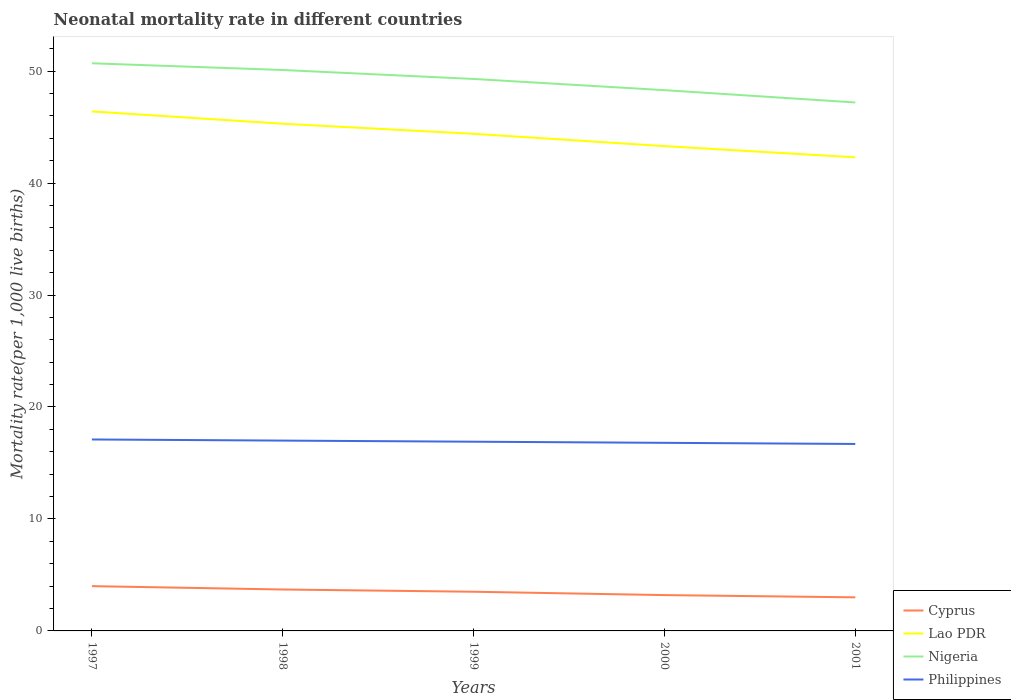How many different coloured lines are there?
Ensure brevity in your answer.  4. Is the number of lines equal to the number of legend labels?
Make the answer very short. Yes. Across all years, what is the maximum neonatal mortality rate in Lao PDR?
Offer a terse response. 42.3. What is the total neonatal mortality rate in Nigeria in the graph?
Your response must be concise. 0.6. What is the difference between the highest and the second highest neonatal mortality rate in Lao PDR?
Offer a terse response. 4.1. What is the difference between the highest and the lowest neonatal mortality rate in Nigeria?
Your answer should be very brief. 3. What is the difference between two consecutive major ticks on the Y-axis?
Make the answer very short. 10. Does the graph contain grids?
Offer a terse response. No. Where does the legend appear in the graph?
Ensure brevity in your answer.  Bottom right. How many legend labels are there?
Provide a succinct answer. 4. What is the title of the graph?
Offer a terse response. Neonatal mortality rate in different countries. Does "Andorra" appear as one of the legend labels in the graph?
Your answer should be compact. No. What is the label or title of the X-axis?
Keep it short and to the point. Years. What is the label or title of the Y-axis?
Provide a succinct answer. Mortality rate(per 1,0 live births). What is the Mortality rate(per 1,000 live births) of Cyprus in 1997?
Your response must be concise. 4. What is the Mortality rate(per 1,000 live births) in Lao PDR in 1997?
Provide a succinct answer. 46.4. What is the Mortality rate(per 1,000 live births) in Nigeria in 1997?
Provide a succinct answer. 50.7. What is the Mortality rate(per 1,000 live births) in Philippines in 1997?
Your answer should be very brief. 17.1. What is the Mortality rate(per 1,000 live births) of Cyprus in 1998?
Make the answer very short. 3.7. What is the Mortality rate(per 1,000 live births) of Lao PDR in 1998?
Give a very brief answer. 45.3. What is the Mortality rate(per 1,000 live births) of Nigeria in 1998?
Your answer should be compact. 50.1. What is the Mortality rate(per 1,000 live births) in Cyprus in 1999?
Give a very brief answer. 3.5. What is the Mortality rate(per 1,000 live births) of Lao PDR in 1999?
Your response must be concise. 44.4. What is the Mortality rate(per 1,000 live births) in Nigeria in 1999?
Offer a very short reply. 49.3. What is the Mortality rate(per 1,000 live births) in Cyprus in 2000?
Offer a very short reply. 3.2. What is the Mortality rate(per 1,000 live births) of Lao PDR in 2000?
Provide a succinct answer. 43.3. What is the Mortality rate(per 1,000 live births) of Nigeria in 2000?
Make the answer very short. 48.3. What is the Mortality rate(per 1,000 live births) of Philippines in 2000?
Make the answer very short. 16.8. What is the Mortality rate(per 1,000 live births) of Cyprus in 2001?
Provide a succinct answer. 3. What is the Mortality rate(per 1,000 live births) of Lao PDR in 2001?
Ensure brevity in your answer.  42.3. What is the Mortality rate(per 1,000 live births) of Nigeria in 2001?
Offer a terse response. 47.2. What is the Mortality rate(per 1,000 live births) of Philippines in 2001?
Give a very brief answer. 16.7. Across all years, what is the maximum Mortality rate(per 1,000 live births) in Cyprus?
Your answer should be compact. 4. Across all years, what is the maximum Mortality rate(per 1,000 live births) in Lao PDR?
Ensure brevity in your answer.  46.4. Across all years, what is the maximum Mortality rate(per 1,000 live births) of Nigeria?
Offer a very short reply. 50.7. Across all years, what is the minimum Mortality rate(per 1,000 live births) of Cyprus?
Ensure brevity in your answer.  3. Across all years, what is the minimum Mortality rate(per 1,000 live births) in Lao PDR?
Offer a very short reply. 42.3. Across all years, what is the minimum Mortality rate(per 1,000 live births) in Nigeria?
Give a very brief answer. 47.2. What is the total Mortality rate(per 1,000 live births) of Lao PDR in the graph?
Your response must be concise. 221.7. What is the total Mortality rate(per 1,000 live births) of Nigeria in the graph?
Keep it short and to the point. 245.6. What is the total Mortality rate(per 1,000 live births) of Philippines in the graph?
Your answer should be compact. 84.5. What is the difference between the Mortality rate(per 1,000 live births) in Cyprus in 1997 and that in 1998?
Provide a short and direct response. 0.3. What is the difference between the Mortality rate(per 1,000 live births) of Lao PDR in 1997 and that in 1999?
Keep it short and to the point. 2. What is the difference between the Mortality rate(per 1,000 live births) in Philippines in 1997 and that in 1999?
Your response must be concise. 0.2. What is the difference between the Mortality rate(per 1,000 live births) of Nigeria in 1997 and that in 2000?
Offer a very short reply. 2.4. What is the difference between the Mortality rate(per 1,000 live births) in Cyprus in 1997 and that in 2001?
Provide a short and direct response. 1. What is the difference between the Mortality rate(per 1,000 live births) in Lao PDR in 1997 and that in 2001?
Offer a very short reply. 4.1. What is the difference between the Mortality rate(per 1,000 live births) in Nigeria in 1997 and that in 2001?
Keep it short and to the point. 3.5. What is the difference between the Mortality rate(per 1,000 live births) in Cyprus in 1998 and that in 1999?
Keep it short and to the point. 0.2. What is the difference between the Mortality rate(per 1,000 live births) in Lao PDR in 1998 and that in 1999?
Offer a very short reply. 0.9. What is the difference between the Mortality rate(per 1,000 live births) of Nigeria in 1998 and that in 1999?
Your response must be concise. 0.8. What is the difference between the Mortality rate(per 1,000 live births) of Nigeria in 1998 and that in 2000?
Offer a terse response. 1.8. What is the difference between the Mortality rate(per 1,000 live births) of Cyprus in 1998 and that in 2001?
Your answer should be very brief. 0.7. What is the difference between the Mortality rate(per 1,000 live births) of Nigeria in 1998 and that in 2001?
Offer a very short reply. 2.9. What is the difference between the Mortality rate(per 1,000 live births) of Philippines in 1998 and that in 2001?
Provide a short and direct response. 0.3. What is the difference between the Mortality rate(per 1,000 live births) of Cyprus in 1999 and that in 2000?
Your answer should be very brief. 0.3. What is the difference between the Mortality rate(per 1,000 live births) in Lao PDR in 1999 and that in 2000?
Your answer should be very brief. 1.1. What is the difference between the Mortality rate(per 1,000 live births) in Nigeria in 1999 and that in 2000?
Offer a very short reply. 1. What is the difference between the Mortality rate(per 1,000 live births) in Cyprus in 1999 and that in 2001?
Give a very brief answer. 0.5. What is the difference between the Mortality rate(per 1,000 live births) of Lao PDR in 1999 and that in 2001?
Offer a very short reply. 2.1. What is the difference between the Mortality rate(per 1,000 live births) in Nigeria in 1999 and that in 2001?
Make the answer very short. 2.1. What is the difference between the Mortality rate(per 1,000 live births) of Nigeria in 2000 and that in 2001?
Offer a terse response. 1.1. What is the difference between the Mortality rate(per 1,000 live births) in Philippines in 2000 and that in 2001?
Provide a succinct answer. 0.1. What is the difference between the Mortality rate(per 1,000 live births) of Cyprus in 1997 and the Mortality rate(per 1,000 live births) of Lao PDR in 1998?
Offer a very short reply. -41.3. What is the difference between the Mortality rate(per 1,000 live births) in Cyprus in 1997 and the Mortality rate(per 1,000 live births) in Nigeria in 1998?
Provide a succinct answer. -46.1. What is the difference between the Mortality rate(per 1,000 live births) in Cyprus in 1997 and the Mortality rate(per 1,000 live births) in Philippines in 1998?
Provide a short and direct response. -13. What is the difference between the Mortality rate(per 1,000 live births) in Lao PDR in 1997 and the Mortality rate(per 1,000 live births) in Nigeria in 1998?
Provide a succinct answer. -3.7. What is the difference between the Mortality rate(per 1,000 live births) in Lao PDR in 1997 and the Mortality rate(per 1,000 live births) in Philippines in 1998?
Your answer should be compact. 29.4. What is the difference between the Mortality rate(per 1,000 live births) in Nigeria in 1997 and the Mortality rate(per 1,000 live births) in Philippines in 1998?
Your response must be concise. 33.7. What is the difference between the Mortality rate(per 1,000 live births) of Cyprus in 1997 and the Mortality rate(per 1,000 live births) of Lao PDR in 1999?
Your response must be concise. -40.4. What is the difference between the Mortality rate(per 1,000 live births) of Cyprus in 1997 and the Mortality rate(per 1,000 live births) of Nigeria in 1999?
Provide a short and direct response. -45.3. What is the difference between the Mortality rate(per 1,000 live births) of Cyprus in 1997 and the Mortality rate(per 1,000 live births) of Philippines in 1999?
Your answer should be compact. -12.9. What is the difference between the Mortality rate(per 1,000 live births) of Lao PDR in 1997 and the Mortality rate(per 1,000 live births) of Nigeria in 1999?
Offer a very short reply. -2.9. What is the difference between the Mortality rate(per 1,000 live births) of Lao PDR in 1997 and the Mortality rate(per 1,000 live births) of Philippines in 1999?
Ensure brevity in your answer.  29.5. What is the difference between the Mortality rate(per 1,000 live births) of Nigeria in 1997 and the Mortality rate(per 1,000 live births) of Philippines in 1999?
Make the answer very short. 33.8. What is the difference between the Mortality rate(per 1,000 live births) in Cyprus in 1997 and the Mortality rate(per 1,000 live births) in Lao PDR in 2000?
Your answer should be very brief. -39.3. What is the difference between the Mortality rate(per 1,000 live births) of Cyprus in 1997 and the Mortality rate(per 1,000 live births) of Nigeria in 2000?
Your answer should be very brief. -44.3. What is the difference between the Mortality rate(per 1,000 live births) of Cyprus in 1997 and the Mortality rate(per 1,000 live births) of Philippines in 2000?
Your response must be concise. -12.8. What is the difference between the Mortality rate(per 1,000 live births) of Lao PDR in 1997 and the Mortality rate(per 1,000 live births) of Philippines in 2000?
Ensure brevity in your answer.  29.6. What is the difference between the Mortality rate(per 1,000 live births) of Nigeria in 1997 and the Mortality rate(per 1,000 live births) of Philippines in 2000?
Offer a very short reply. 33.9. What is the difference between the Mortality rate(per 1,000 live births) in Cyprus in 1997 and the Mortality rate(per 1,000 live births) in Lao PDR in 2001?
Your answer should be compact. -38.3. What is the difference between the Mortality rate(per 1,000 live births) of Cyprus in 1997 and the Mortality rate(per 1,000 live births) of Nigeria in 2001?
Make the answer very short. -43.2. What is the difference between the Mortality rate(per 1,000 live births) of Cyprus in 1997 and the Mortality rate(per 1,000 live births) of Philippines in 2001?
Ensure brevity in your answer.  -12.7. What is the difference between the Mortality rate(per 1,000 live births) of Lao PDR in 1997 and the Mortality rate(per 1,000 live births) of Nigeria in 2001?
Offer a terse response. -0.8. What is the difference between the Mortality rate(per 1,000 live births) of Lao PDR in 1997 and the Mortality rate(per 1,000 live births) of Philippines in 2001?
Your answer should be very brief. 29.7. What is the difference between the Mortality rate(per 1,000 live births) of Nigeria in 1997 and the Mortality rate(per 1,000 live births) of Philippines in 2001?
Offer a very short reply. 34. What is the difference between the Mortality rate(per 1,000 live births) of Cyprus in 1998 and the Mortality rate(per 1,000 live births) of Lao PDR in 1999?
Offer a very short reply. -40.7. What is the difference between the Mortality rate(per 1,000 live births) of Cyprus in 1998 and the Mortality rate(per 1,000 live births) of Nigeria in 1999?
Your answer should be very brief. -45.6. What is the difference between the Mortality rate(per 1,000 live births) of Cyprus in 1998 and the Mortality rate(per 1,000 live births) of Philippines in 1999?
Provide a short and direct response. -13.2. What is the difference between the Mortality rate(per 1,000 live births) in Lao PDR in 1998 and the Mortality rate(per 1,000 live births) in Nigeria in 1999?
Make the answer very short. -4. What is the difference between the Mortality rate(per 1,000 live births) of Lao PDR in 1998 and the Mortality rate(per 1,000 live births) of Philippines in 1999?
Make the answer very short. 28.4. What is the difference between the Mortality rate(per 1,000 live births) in Nigeria in 1998 and the Mortality rate(per 1,000 live births) in Philippines in 1999?
Give a very brief answer. 33.2. What is the difference between the Mortality rate(per 1,000 live births) in Cyprus in 1998 and the Mortality rate(per 1,000 live births) in Lao PDR in 2000?
Your answer should be compact. -39.6. What is the difference between the Mortality rate(per 1,000 live births) of Cyprus in 1998 and the Mortality rate(per 1,000 live births) of Nigeria in 2000?
Make the answer very short. -44.6. What is the difference between the Mortality rate(per 1,000 live births) of Lao PDR in 1998 and the Mortality rate(per 1,000 live births) of Nigeria in 2000?
Provide a succinct answer. -3. What is the difference between the Mortality rate(per 1,000 live births) in Nigeria in 1998 and the Mortality rate(per 1,000 live births) in Philippines in 2000?
Offer a very short reply. 33.3. What is the difference between the Mortality rate(per 1,000 live births) in Cyprus in 1998 and the Mortality rate(per 1,000 live births) in Lao PDR in 2001?
Offer a terse response. -38.6. What is the difference between the Mortality rate(per 1,000 live births) of Cyprus in 1998 and the Mortality rate(per 1,000 live births) of Nigeria in 2001?
Provide a short and direct response. -43.5. What is the difference between the Mortality rate(per 1,000 live births) in Cyprus in 1998 and the Mortality rate(per 1,000 live births) in Philippines in 2001?
Keep it short and to the point. -13. What is the difference between the Mortality rate(per 1,000 live births) of Lao PDR in 1998 and the Mortality rate(per 1,000 live births) of Philippines in 2001?
Provide a succinct answer. 28.6. What is the difference between the Mortality rate(per 1,000 live births) of Nigeria in 1998 and the Mortality rate(per 1,000 live births) of Philippines in 2001?
Your response must be concise. 33.4. What is the difference between the Mortality rate(per 1,000 live births) of Cyprus in 1999 and the Mortality rate(per 1,000 live births) of Lao PDR in 2000?
Your answer should be compact. -39.8. What is the difference between the Mortality rate(per 1,000 live births) of Cyprus in 1999 and the Mortality rate(per 1,000 live births) of Nigeria in 2000?
Your response must be concise. -44.8. What is the difference between the Mortality rate(per 1,000 live births) of Cyprus in 1999 and the Mortality rate(per 1,000 live births) of Philippines in 2000?
Provide a short and direct response. -13.3. What is the difference between the Mortality rate(per 1,000 live births) in Lao PDR in 1999 and the Mortality rate(per 1,000 live births) in Nigeria in 2000?
Give a very brief answer. -3.9. What is the difference between the Mortality rate(per 1,000 live births) of Lao PDR in 1999 and the Mortality rate(per 1,000 live births) of Philippines in 2000?
Ensure brevity in your answer.  27.6. What is the difference between the Mortality rate(per 1,000 live births) in Nigeria in 1999 and the Mortality rate(per 1,000 live births) in Philippines in 2000?
Your response must be concise. 32.5. What is the difference between the Mortality rate(per 1,000 live births) of Cyprus in 1999 and the Mortality rate(per 1,000 live births) of Lao PDR in 2001?
Your answer should be compact. -38.8. What is the difference between the Mortality rate(per 1,000 live births) of Cyprus in 1999 and the Mortality rate(per 1,000 live births) of Nigeria in 2001?
Ensure brevity in your answer.  -43.7. What is the difference between the Mortality rate(per 1,000 live births) of Lao PDR in 1999 and the Mortality rate(per 1,000 live births) of Nigeria in 2001?
Your response must be concise. -2.8. What is the difference between the Mortality rate(per 1,000 live births) of Lao PDR in 1999 and the Mortality rate(per 1,000 live births) of Philippines in 2001?
Make the answer very short. 27.7. What is the difference between the Mortality rate(per 1,000 live births) in Nigeria in 1999 and the Mortality rate(per 1,000 live births) in Philippines in 2001?
Provide a short and direct response. 32.6. What is the difference between the Mortality rate(per 1,000 live births) of Cyprus in 2000 and the Mortality rate(per 1,000 live births) of Lao PDR in 2001?
Offer a very short reply. -39.1. What is the difference between the Mortality rate(per 1,000 live births) of Cyprus in 2000 and the Mortality rate(per 1,000 live births) of Nigeria in 2001?
Offer a terse response. -44. What is the difference between the Mortality rate(per 1,000 live births) of Lao PDR in 2000 and the Mortality rate(per 1,000 live births) of Philippines in 2001?
Make the answer very short. 26.6. What is the difference between the Mortality rate(per 1,000 live births) of Nigeria in 2000 and the Mortality rate(per 1,000 live births) of Philippines in 2001?
Your answer should be very brief. 31.6. What is the average Mortality rate(per 1,000 live births) in Cyprus per year?
Offer a terse response. 3.48. What is the average Mortality rate(per 1,000 live births) in Lao PDR per year?
Provide a succinct answer. 44.34. What is the average Mortality rate(per 1,000 live births) of Nigeria per year?
Offer a very short reply. 49.12. What is the average Mortality rate(per 1,000 live births) of Philippines per year?
Offer a terse response. 16.9. In the year 1997, what is the difference between the Mortality rate(per 1,000 live births) in Cyprus and Mortality rate(per 1,000 live births) in Lao PDR?
Offer a very short reply. -42.4. In the year 1997, what is the difference between the Mortality rate(per 1,000 live births) of Cyprus and Mortality rate(per 1,000 live births) of Nigeria?
Give a very brief answer. -46.7. In the year 1997, what is the difference between the Mortality rate(per 1,000 live births) of Cyprus and Mortality rate(per 1,000 live births) of Philippines?
Your answer should be compact. -13.1. In the year 1997, what is the difference between the Mortality rate(per 1,000 live births) of Lao PDR and Mortality rate(per 1,000 live births) of Philippines?
Provide a short and direct response. 29.3. In the year 1997, what is the difference between the Mortality rate(per 1,000 live births) in Nigeria and Mortality rate(per 1,000 live births) in Philippines?
Give a very brief answer. 33.6. In the year 1998, what is the difference between the Mortality rate(per 1,000 live births) in Cyprus and Mortality rate(per 1,000 live births) in Lao PDR?
Give a very brief answer. -41.6. In the year 1998, what is the difference between the Mortality rate(per 1,000 live births) of Cyprus and Mortality rate(per 1,000 live births) of Nigeria?
Your answer should be compact. -46.4. In the year 1998, what is the difference between the Mortality rate(per 1,000 live births) in Cyprus and Mortality rate(per 1,000 live births) in Philippines?
Your answer should be compact. -13.3. In the year 1998, what is the difference between the Mortality rate(per 1,000 live births) of Lao PDR and Mortality rate(per 1,000 live births) of Philippines?
Offer a terse response. 28.3. In the year 1998, what is the difference between the Mortality rate(per 1,000 live births) of Nigeria and Mortality rate(per 1,000 live births) of Philippines?
Make the answer very short. 33.1. In the year 1999, what is the difference between the Mortality rate(per 1,000 live births) of Cyprus and Mortality rate(per 1,000 live births) of Lao PDR?
Give a very brief answer. -40.9. In the year 1999, what is the difference between the Mortality rate(per 1,000 live births) of Cyprus and Mortality rate(per 1,000 live births) of Nigeria?
Give a very brief answer. -45.8. In the year 1999, what is the difference between the Mortality rate(per 1,000 live births) of Nigeria and Mortality rate(per 1,000 live births) of Philippines?
Give a very brief answer. 32.4. In the year 2000, what is the difference between the Mortality rate(per 1,000 live births) of Cyprus and Mortality rate(per 1,000 live births) of Lao PDR?
Provide a short and direct response. -40.1. In the year 2000, what is the difference between the Mortality rate(per 1,000 live births) of Cyprus and Mortality rate(per 1,000 live births) of Nigeria?
Your answer should be compact. -45.1. In the year 2000, what is the difference between the Mortality rate(per 1,000 live births) in Lao PDR and Mortality rate(per 1,000 live births) in Nigeria?
Provide a short and direct response. -5. In the year 2000, what is the difference between the Mortality rate(per 1,000 live births) of Lao PDR and Mortality rate(per 1,000 live births) of Philippines?
Ensure brevity in your answer.  26.5. In the year 2000, what is the difference between the Mortality rate(per 1,000 live births) of Nigeria and Mortality rate(per 1,000 live births) of Philippines?
Offer a terse response. 31.5. In the year 2001, what is the difference between the Mortality rate(per 1,000 live births) of Cyprus and Mortality rate(per 1,000 live births) of Lao PDR?
Provide a short and direct response. -39.3. In the year 2001, what is the difference between the Mortality rate(per 1,000 live births) of Cyprus and Mortality rate(per 1,000 live births) of Nigeria?
Provide a succinct answer. -44.2. In the year 2001, what is the difference between the Mortality rate(per 1,000 live births) in Cyprus and Mortality rate(per 1,000 live births) in Philippines?
Your answer should be compact. -13.7. In the year 2001, what is the difference between the Mortality rate(per 1,000 live births) of Lao PDR and Mortality rate(per 1,000 live births) of Nigeria?
Make the answer very short. -4.9. In the year 2001, what is the difference between the Mortality rate(per 1,000 live births) of Lao PDR and Mortality rate(per 1,000 live births) of Philippines?
Your response must be concise. 25.6. In the year 2001, what is the difference between the Mortality rate(per 1,000 live births) of Nigeria and Mortality rate(per 1,000 live births) of Philippines?
Offer a terse response. 30.5. What is the ratio of the Mortality rate(per 1,000 live births) in Cyprus in 1997 to that in 1998?
Keep it short and to the point. 1.08. What is the ratio of the Mortality rate(per 1,000 live births) of Lao PDR in 1997 to that in 1998?
Offer a very short reply. 1.02. What is the ratio of the Mortality rate(per 1,000 live births) in Philippines in 1997 to that in 1998?
Your answer should be very brief. 1.01. What is the ratio of the Mortality rate(per 1,000 live births) in Lao PDR in 1997 to that in 1999?
Offer a very short reply. 1.04. What is the ratio of the Mortality rate(per 1,000 live births) in Nigeria in 1997 to that in 1999?
Make the answer very short. 1.03. What is the ratio of the Mortality rate(per 1,000 live births) in Philippines in 1997 to that in 1999?
Provide a short and direct response. 1.01. What is the ratio of the Mortality rate(per 1,000 live births) in Cyprus in 1997 to that in 2000?
Provide a short and direct response. 1.25. What is the ratio of the Mortality rate(per 1,000 live births) in Lao PDR in 1997 to that in 2000?
Offer a terse response. 1.07. What is the ratio of the Mortality rate(per 1,000 live births) in Nigeria in 1997 to that in 2000?
Provide a succinct answer. 1.05. What is the ratio of the Mortality rate(per 1,000 live births) in Philippines in 1997 to that in 2000?
Provide a succinct answer. 1.02. What is the ratio of the Mortality rate(per 1,000 live births) of Lao PDR in 1997 to that in 2001?
Provide a short and direct response. 1.1. What is the ratio of the Mortality rate(per 1,000 live births) of Nigeria in 1997 to that in 2001?
Offer a very short reply. 1.07. What is the ratio of the Mortality rate(per 1,000 live births) of Philippines in 1997 to that in 2001?
Give a very brief answer. 1.02. What is the ratio of the Mortality rate(per 1,000 live births) of Cyprus in 1998 to that in 1999?
Make the answer very short. 1.06. What is the ratio of the Mortality rate(per 1,000 live births) of Lao PDR in 1998 to that in 1999?
Your response must be concise. 1.02. What is the ratio of the Mortality rate(per 1,000 live births) in Nigeria in 1998 to that in 1999?
Give a very brief answer. 1.02. What is the ratio of the Mortality rate(per 1,000 live births) of Philippines in 1998 to that in 1999?
Provide a short and direct response. 1.01. What is the ratio of the Mortality rate(per 1,000 live births) of Cyprus in 1998 to that in 2000?
Provide a short and direct response. 1.16. What is the ratio of the Mortality rate(per 1,000 live births) in Lao PDR in 1998 to that in 2000?
Offer a terse response. 1.05. What is the ratio of the Mortality rate(per 1,000 live births) in Nigeria in 1998 to that in 2000?
Your answer should be compact. 1.04. What is the ratio of the Mortality rate(per 1,000 live births) of Philippines in 1998 to that in 2000?
Provide a short and direct response. 1.01. What is the ratio of the Mortality rate(per 1,000 live births) in Cyprus in 1998 to that in 2001?
Ensure brevity in your answer.  1.23. What is the ratio of the Mortality rate(per 1,000 live births) of Lao PDR in 1998 to that in 2001?
Provide a short and direct response. 1.07. What is the ratio of the Mortality rate(per 1,000 live births) in Nigeria in 1998 to that in 2001?
Your response must be concise. 1.06. What is the ratio of the Mortality rate(per 1,000 live births) of Philippines in 1998 to that in 2001?
Your answer should be compact. 1.02. What is the ratio of the Mortality rate(per 1,000 live births) in Cyprus in 1999 to that in 2000?
Offer a very short reply. 1.09. What is the ratio of the Mortality rate(per 1,000 live births) of Lao PDR in 1999 to that in 2000?
Make the answer very short. 1.03. What is the ratio of the Mortality rate(per 1,000 live births) of Nigeria in 1999 to that in 2000?
Provide a succinct answer. 1.02. What is the ratio of the Mortality rate(per 1,000 live births) of Lao PDR in 1999 to that in 2001?
Provide a succinct answer. 1.05. What is the ratio of the Mortality rate(per 1,000 live births) of Nigeria in 1999 to that in 2001?
Offer a very short reply. 1.04. What is the ratio of the Mortality rate(per 1,000 live births) of Philippines in 1999 to that in 2001?
Your response must be concise. 1.01. What is the ratio of the Mortality rate(per 1,000 live births) of Cyprus in 2000 to that in 2001?
Your answer should be compact. 1.07. What is the ratio of the Mortality rate(per 1,000 live births) of Lao PDR in 2000 to that in 2001?
Your answer should be compact. 1.02. What is the ratio of the Mortality rate(per 1,000 live births) in Nigeria in 2000 to that in 2001?
Your answer should be compact. 1.02. What is the ratio of the Mortality rate(per 1,000 live births) of Philippines in 2000 to that in 2001?
Provide a succinct answer. 1.01. What is the difference between the highest and the second highest Mortality rate(per 1,000 live births) of Nigeria?
Your response must be concise. 0.6. What is the difference between the highest and the second highest Mortality rate(per 1,000 live births) of Philippines?
Give a very brief answer. 0.1. 